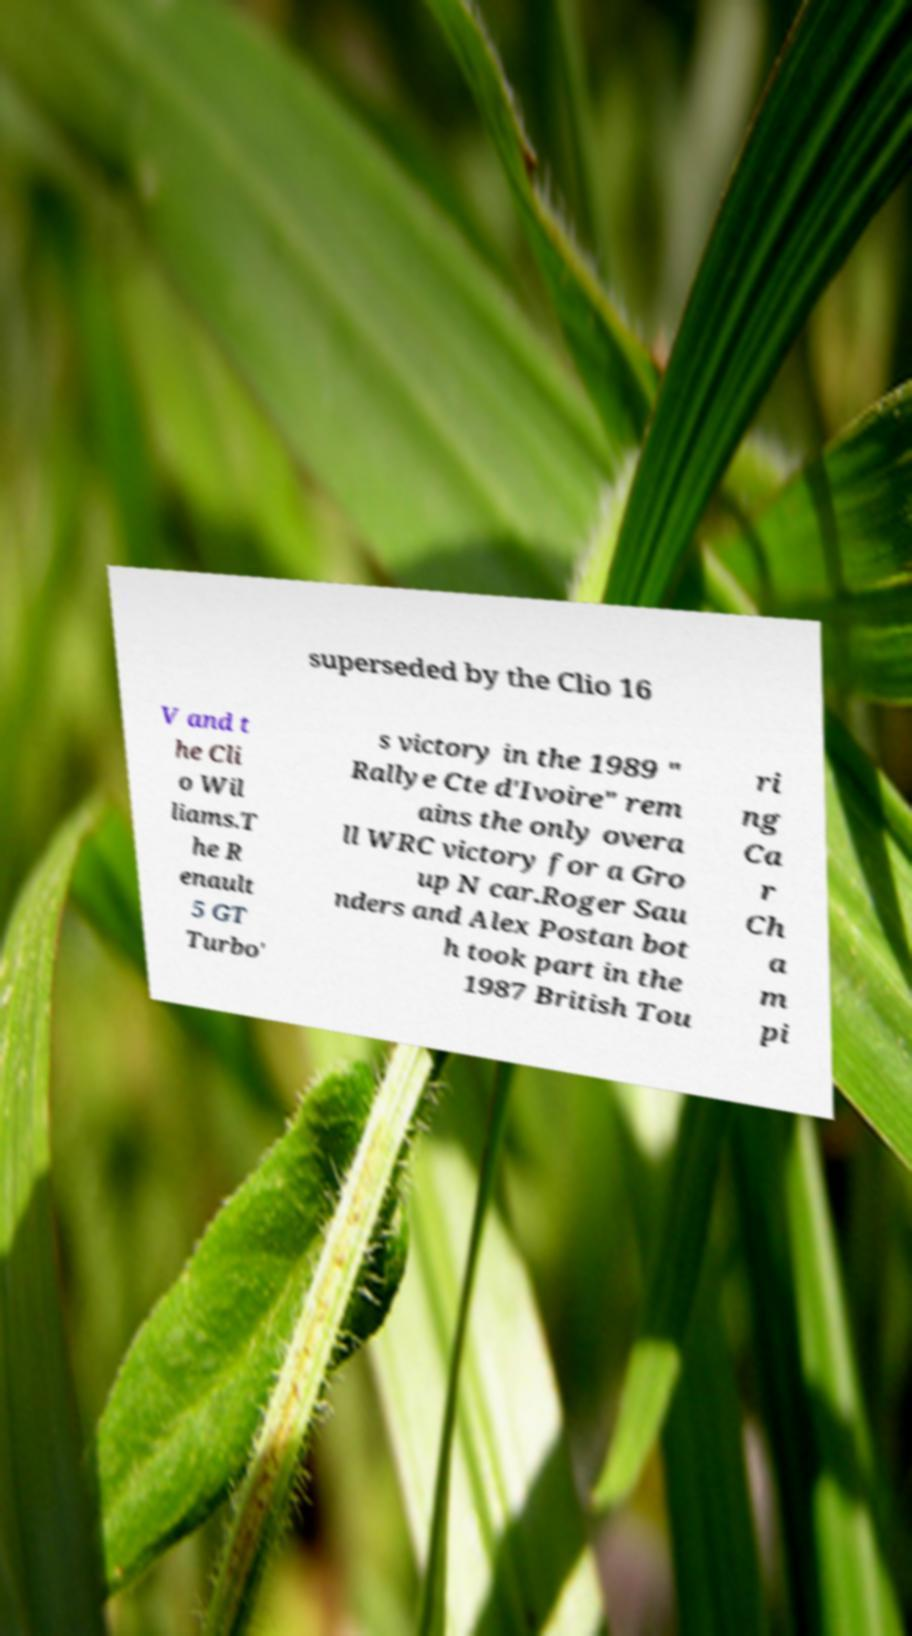What messages or text are displayed in this image? I need them in a readable, typed format. superseded by the Clio 16 V and t he Cli o Wil liams.T he R enault 5 GT Turbo' s victory in the 1989 " Rallye Cte d'Ivoire" rem ains the only overa ll WRC victory for a Gro up N car.Roger Sau nders and Alex Postan bot h took part in the 1987 British Tou ri ng Ca r Ch a m pi 